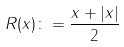<formula> <loc_0><loc_0><loc_500><loc_500>R ( x ) \colon = \frac { x + | x | } { 2 }</formula> 